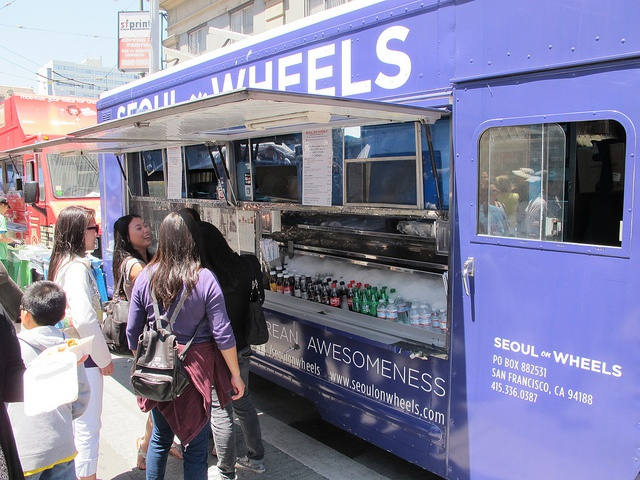Describe the objects in this image and their specific colors. I can see truck in lavender, violet, black, gray, and darkgray tones, people in lavender, black, gray, maroon, and darkgray tones, people in lavender, white, darkgray, gray, and black tones, truck in lavender, ivory, lightpink, darkgray, and salmon tones, and people in lavender, black, gray, darkgray, and lightgray tones in this image. 